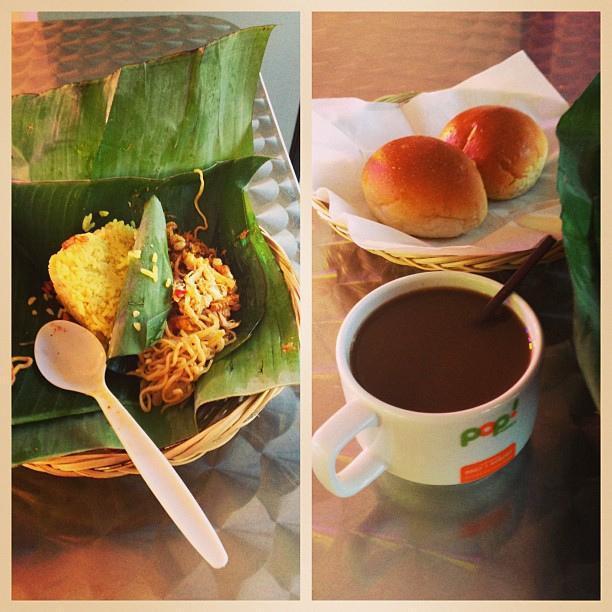How many rolls are in this photo?
Give a very brief answer. 2. How many dining tables are in the picture?
Give a very brief answer. 2. How many men are wearing hats?
Give a very brief answer. 0. 